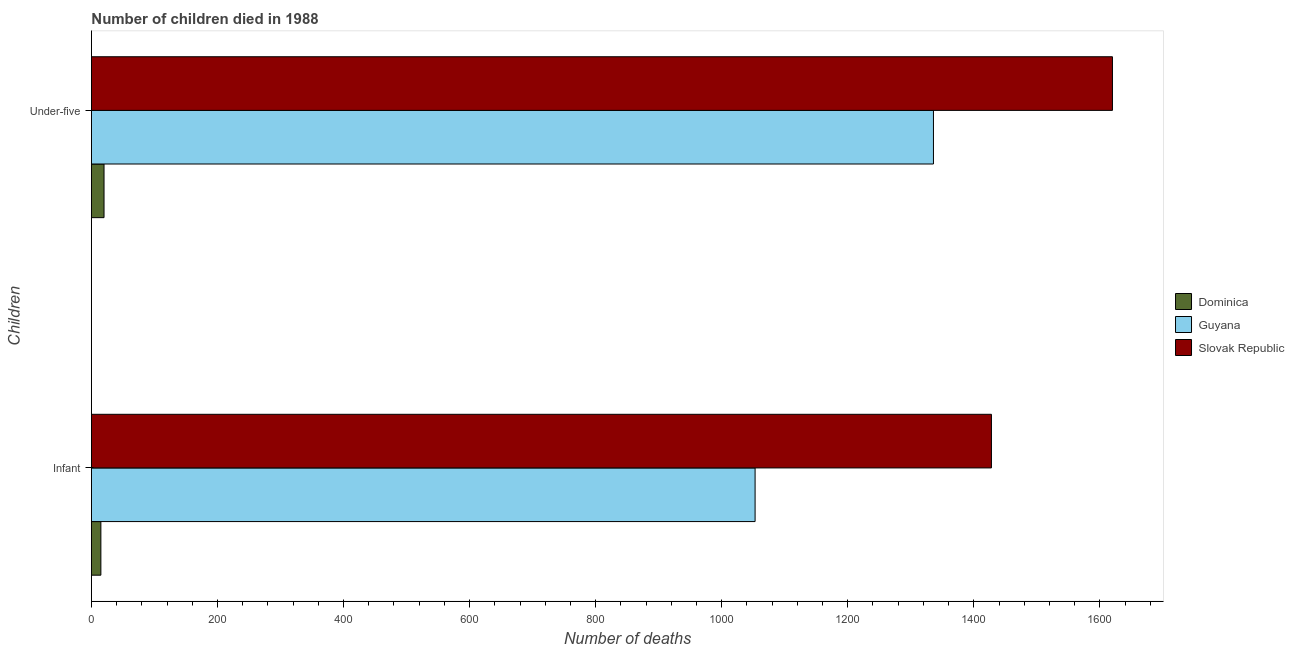Are the number of bars per tick equal to the number of legend labels?
Provide a short and direct response. Yes. Are the number of bars on each tick of the Y-axis equal?
Ensure brevity in your answer.  Yes. How many bars are there on the 1st tick from the top?
Your answer should be very brief. 3. What is the label of the 2nd group of bars from the top?
Provide a succinct answer. Infant. What is the number of infant deaths in Slovak Republic?
Ensure brevity in your answer.  1428. Across all countries, what is the maximum number of under-five deaths?
Your answer should be compact. 1620. Across all countries, what is the minimum number of under-five deaths?
Offer a terse response. 20. In which country was the number of infant deaths maximum?
Your answer should be very brief. Slovak Republic. In which country was the number of infant deaths minimum?
Provide a succinct answer. Dominica. What is the total number of under-five deaths in the graph?
Your answer should be compact. 2976. What is the difference between the number of infant deaths in Guyana and that in Dominica?
Offer a very short reply. 1038. What is the difference between the number of under-five deaths in Guyana and the number of infant deaths in Slovak Republic?
Keep it short and to the point. -92. What is the average number of under-five deaths per country?
Ensure brevity in your answer.  992. What is the difference between the number of under-five deaths and number of infant deaths in Dominica?
Offer a terse response. 5. What is the ratio of the number of infant deaths in Slovak Republic to that in Guyana?
Provide a succinct answer. 1.36. Is the number of infant deaths in Slovak Republic less than that in Guyana?
Make the answer very short. No. What does the 3rd bar from the top in Infant represents?
Offer a terse response. Dominica. What does the 2nd bar from the bottom in Infant represents?
Make the answer very short. Guyana. Are all the bars in the graph horizontal?
Your response must be concise. Yes. Are the values on the major ticks of X-axis written in scientific E-notation?
Your answer should be compact. No. How many legend labels are there?
Offer a very short reply. 3. What is the title of the graph?
Offer a very short reply. Number of children died in 1988. What is the label or title of the X-axis?
Offer a terse response. Number of deaths. What is the label or title of the Y-axis?
Provide a succinct answer. Children. What is the Number of deaths of Dominica in Infant?
Your response must be concise. 15. What is the Number of deaths in Guyana in Infant?
Your answer should be compact. 1053. What is the Number of deaths of Slovak Republic in Infant?
Make the answer very short. 1428. What is the Number of deaths of Dominica in Under-five?
Your answer should be very brief. 20. What is the Number of deaths of Guyana in Under-five?
Your answer should be compact. 1336. What is the Number of deaths in Slovak Republic in Under-five?
Offer a very short reply. 1620. Across all Children, what is the maximum Number of deaths of Guyana?
Your response must be concise. 1336. Across all Children, what is the maximum Number of deaths of Slovak Republic?
Provide a succinct answer. 1620. Across all Children, what is the minimum Number of deaths of Dominica?
Your response must be concise. 15. Across all Children, what is the minimum Number of deaths in Guyana?
Your answer should be very brief. 1053. Across all Children, what is the minimum Number of deaths of Slovak Republic?
Offer a terse response. 1428. What is the total Number of deaths in Dominica in the graph?
Provide a succinct answer. 35. What is the total Number of deaths in Guyana in the graph?
Ensure brevity in your answer.  2389. What is the total Number of deaths in Slovak Republic in the graph?
Offer a terse response. 3048. What is the difference between the Number of deaths in Dominica in Infant and that in Under-five?
Give a very brief answer. -5. What is the difference between the Number of deaths in Guyana in Infant and that in Under-five?
Provide a short and direct response. -283. What is the difference between the Number of deaths of Slovak Republic in Infant and that in Under-five?
Ensure brevity in your answer.  -192. What is the difference between the Number of deaths of Dominica in Infant and the Number of deaths of Guyana in Under-five?
Keep it short and to the point. -1321. What is the difference between the Number of deaths in Dominica in Infant and the Number of deaths in Slovak Republic in Under-five?
Provide a succinct answer. -1605. What is the difference between the Number of deaths in Guyana in Infant and the Number of deaths in Slovak Republic in Under-five?
Offer a terse response. -567. What is the average Number of deaths in Dominica per Children?
Keep it short and to the point. 17.5. What is the average Number of deaths of Guyana per Children?
Make the answer very short. 1194.5. What is the average Number of deaths of Slovak Republic per Children?
Ensure brevity in your answer.  1524. What is the difference between the Number of deaths of Dominica and Number of deaths of Guyana in Infant?
Make the answer very short. -1038. What is the difference between the Number of deaths in Dominica and Number of deaths in Slovak Republic in Infant?
Offer a very short reply. -1413. What is the difference between the Number of deaths of Guyana and Number of deaths of Slovak Republic in Infant?
Give a very brief answer. -375. What is the difference between the Number of deaths of Dominica and Number of deaths of Guyana in Under-five?
Offer a terse response. -1316. What is the difference between the Number of deaths in Dominica and Number of deaths in Slovak Republic in Under-five?
Offer a terse response. -1600. What is the difference between the Number of deaths of Guyana and Number of deaths of Slovak Republic in Under-five?
Your response must be concise. -284. What is the ratio of the Number of deaths of Dominica in Infant to that in Under-five?
Make the answer very short. 0.75. What is the ratio of the Number of deaths of Guyana in Infant to that in Under-five?
Provide a short and direct response. 0.79. What is the ratio of the Number of deaths in Slovak Republic in Infant to that in Under-five?
Provide a succinct answer. 0.88. What is the difference between the highest and the second highest Number of deaths of Dominica?
Make the answer very short. 5. What is the difference between the highest and the second highest Number of deaths in Guyana?
Make the answer very short. 283. What is the difference between the highest and the second highest Number of deaths in Slovak Republic?
Give a very brief answer. 192. What is the difference between the highest and the lowest Number of deaths in Dominica?
Make the answer very short. 5. What is the difference between the highest and the lowest Number of deaths in Guyana?
Ensure brevity in your answer.  283. What is the difference between the highest and the lowest Number of deaths of Slovak Republic?
Keep it short and to the point. 192. 